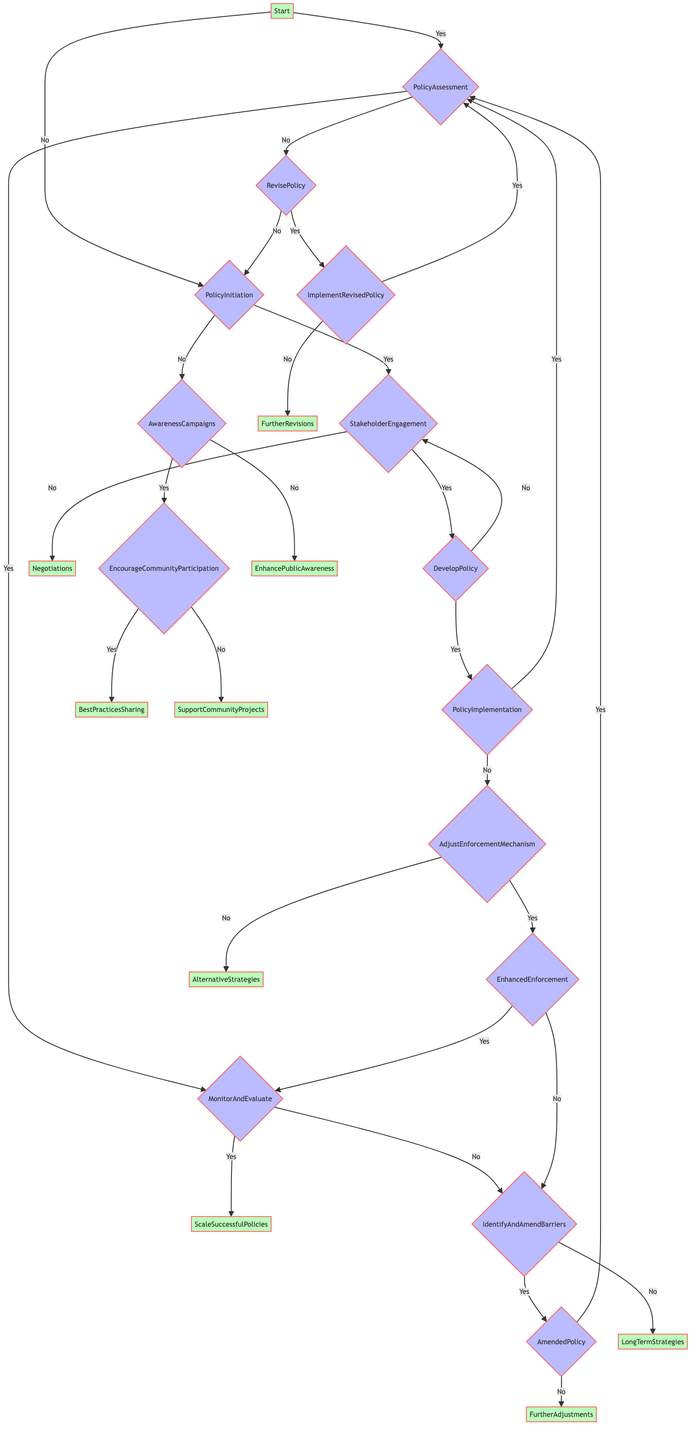What is the first question in the Decision Tree? The first question in the Decision Tree, starting from the "Start" node, asks whether there is an existing plastic reduction policy in the city.
Answer: Is there an existing plastic reduction policy in the city? What do you do if local authorities are not willing to develop a policy? If local authorities are not willing to develop a policy, the next action is to conduct awareness campaigns, as indicated by the "no" path from the "PolicyInitiation" node.
Answer: AwarenessCampaigns How many total decision nodes are in the diagram? By counting all the major decision points throughout the flowchart, there are a total of 10 decision nodes, including Start, PolicyInitiation, StakeholderEngagement, DevelopPolicy, PolicyImplementation, PolicyAssessment, MonitorAndEvaluate, AdjustEnforcementMechanism, RevisePolicy, and AmendedPolicy.
Answer: 10 What is the outcome if community-led initiatives are not reducing plastic usage? If community-led initiatives are not reducing plastic usage, the next step according to the flowchart is to support community projects, which is shown as the "no" option in the "EncourageCommunityParticipation" node.
Answer: SupportCommunityProjects What happens if the revised policy is not effective? If the revised policy is not effective, the subsequent step according to the flowchart is to make further revisions, as indicated by the "no" path from the "ImplementRevisedPolicy" node.
Answer: FurtherRevisions If there is support from key stakeholders, what is the next action? If there is support from key stakeholders, the next action in the decision tree is to develop the policy, as shown by the "yes" path leading to the "DevelopPolicy" node from "StakeholderEngagement".
Answer: DevelopPolicy What is the last decision point before evaluating policy effectiveness? The last decision point before evaluating policy effectiveness is in the "MonitorAndEvaluate" node, where it assesses if the targets for plastic reduction are being met consistently.
Answer: MonitorAndEvaluate What step follows the assessment of a policy if targets are not being met? When targets for plastic reduction are not being met, the next step is to identify and amend barriers, as indicated by the "no" option from the "MonitorAndEvaluate" node.
Answer: IdentifyAndAmendBarriers What does the diagram suggest if enforcement mechanisms cannot be strengthened? If the enforcement mechanisms cannot be strengthened, the diagram suggests exploring alternative strategies, which is the outcome when the answer is "no" at the "AdjustEnforcementMechanism" decision point.
Answer: AlternativeStrategies 